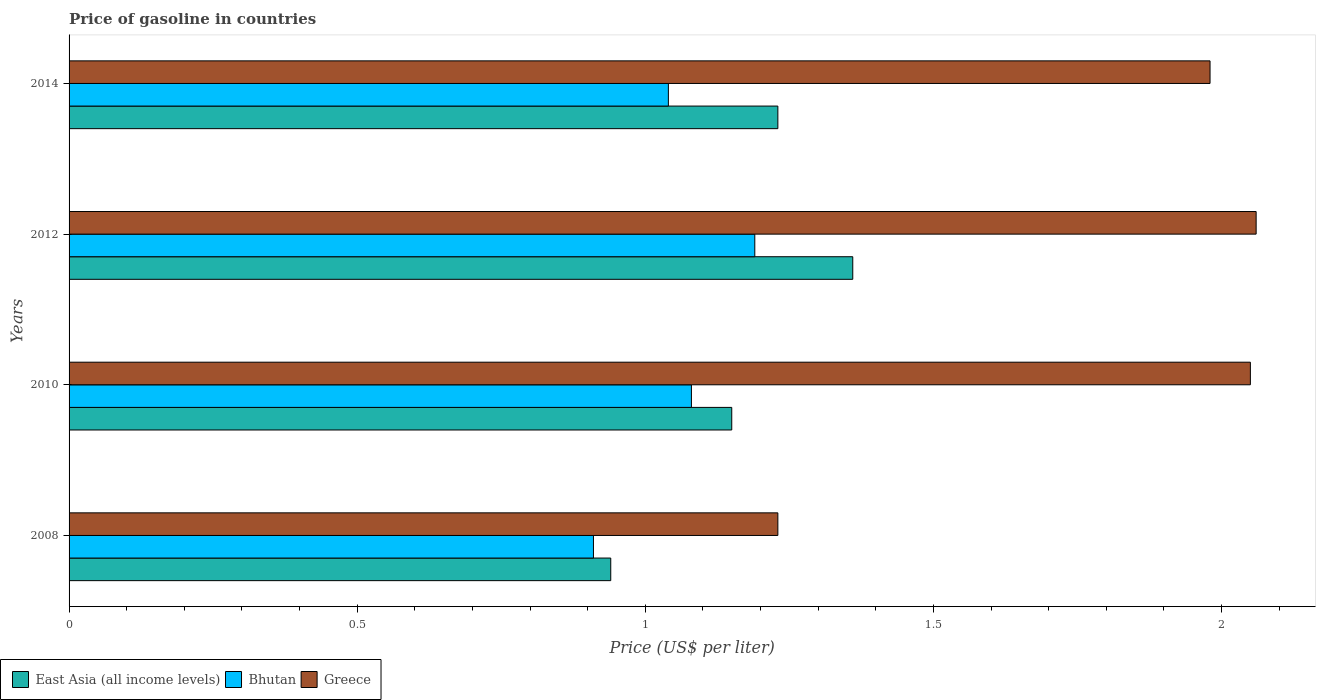How many different coloured bars are there?
Offer a terse response. 3. Are the number of bars on each tick of the Y-axis equal?
Your answer should be compact. Yes. How many bars are there on the 4th tick from the top?
Your answer should be compact. 3. What is the label of the 4th group of bars from the top?
Your response must be concise. 2008. In how many cases, is the number of bars for a given year not equal to the number of legend labels?
Provide a succinct answer. 0. What is the price of gasoline in Bhutan in 2008?
Your response must be concise. 0.91. Across all years, what is the maximum price of gasoline in Greece?
Ensure brevity in your answer.  2.06. Across all years, what is the minimum price of gasoline in Greece?
Provide a short and direct response. 1.23. What is the total price of gasoline in East Asia (all income levels) in the graph?
Offer a terse response. 4.68. What is the difference between the price of gasoline in East Asia (all income levels) in 2008 and that in 2014?
Provide a succinct answer. -0.29. What is the difference between the price of gasoline in East Asia (all income levels) in 2010 and the price of gasoline in Greece in 2014?
Keep it short and to the point. -0.83. What is the average price of gasoline in Bhutan per year?
Give a very brief answer. 1.06. In the year 2012, what is the difference between the price of gasoline in Greece and price of gasoline in Bhutan?
Your answer should be compact. 0.87. What is the ratio of the price of gasoline in Greece in 2010 to that in 2014?
Provide a succinct answer. 1.04. Is the price of gasoline in Greece in 2010 less than that in 2014?
Keep it short and to the point. No. What is the difference between the highest and the second highest price of gasoline in East Asia (all income levels)?
Offer a very short reply. 0.13. What is the difference between the highest and the lowest price of gasoline in Bhutan?
Keep it short and to the point. 0.28. Is the sum of the price of gasoline in East Asia (all income levels) in 2010 and 2014 greater than the maximum price of gasoline in Bhutan across all years?
Your answer should be very brief. Yes. What does the 3rd bar from the top in 2012 represents?
Your answer should be very brief. East Asia (all income levels). What does the 2nd bar from the bottom in 2008 represents?
Make the answer very short. Bhutan. How many bars are there?
Your response must be concise. 12. Are all the bars in the graph horizontal?
Your response must be concise. Yes. How many years are there in the graph?
Offer a very short reply. 4. Are the values on the major ticks of X-axis written in scientific E-notation?
Your answer should be very brief. No. Does the graph contain any zero values?
Give a very brief answer. No. Does the graph contain grids?
Your response must be concise. No. How many legend labels are there?
Make the answer very short. 3. How are the legend labels stacked?
Your answer should be very brief. Horizontal. What is the title of the graph?
Your response must be concise. Price of gasoline in countries. What is the label or title of the X-axis?
Your answer should be compact. Price (US$ per liter). What is the Price (US$ per liter) in Bhutan in 2008?
Provide a short and direct response. 0.91. What is the Price (US$ per liter) of Greece in 2008?
Provide a succinct answer. 1.23. What is the Price (US$ per liter) of East Asia (all income levels) in 2010?
Provide a short and direct response. 1.15. What is the Price (US$ per liter) in Bhutan in 2010?
Offer a very short reply. 1.08. What is the Price (US$ per liter) in Greece in 2010?
Offer a terse response. 2.05. What is the Price (US$ per liter) in East Asia (all income levels) in 2012?
Offer a terse response. 1.36. What is the Price (US$ per liter) of Bhutan in 2012?
Your response must be concise. 1.19. What is the Price (US$ per liter) in Greece in 2012?
Provide a succinct answer. 2.06. What is the Price (US$ per liter) in East Asia (all income levels) in 2014?
Keep it short and to the point. 1.23. What is the Price (US$ per liter) in Bhutan in 2014?
Provide a short and direct response. 1.04. What is the Price (US$ per liter) in Greece in 2014?
Offer a terse response. 1.98. Across all years, what is the maximum Price (US$ per liter) of East Asia (all income levels)?
Give a very brief answer. 1.36. Across all years, what is the maximum Price (US$ per liter) of Bhutan?
Provide a short and direct response. 1.19. Across all years, what is the maximum Price (US$ per liter) in Greece?
Ensure brevity in your answer.  2.06. Across all years, what is the minimum Price (US$ per liter) in East Asia (all income levels)?
Offer a very short reply. 0.94. Across all years, what is the minimum Price (US$ per liter) of Bhutan?
Give a very brief answer. 0.91. Across all years, what is the minimum Price (US$ per liter) in Greece?
Ensure brevity in your answer.  1.23. What is the total Price (US$ per liter) of East Asia (all income levels) in the graph?
Keep it short and to the point. 4.68. What is the total Price (US$ per liter) of Bhutan in the graph?
Provide a short and direct response. 4.22. What is the total Price (US$ per liter) in Greece in the graph?
Provide a succinct answer. 7.32. What is the difference between the Price (US$ per liter) in East Asia (all income levels) in 2008 and that in 2010?
Your response must be concise. -0.21. What is the difference between the Price (US$ per liter) of Bhutan in 2008 and that in 2010?
Make the answer very short. -0.17. What is the difference between the Price (US$ per liter) in Greece in 2008 and that in 2010?
Your answer should be compact. -0.82. What is the difference between the Price (US$ per liter) of East Asia (all income levels) in 2008 and that in 2012?
Offer a very short reply. -0.42. What is the difference between the Price (US$ per liter) of Bhutan in 2008 and that in 2012?
Make the answer very short. -0.28. What is the difference between the Price (US$ per liter) of Greece in 2008 and that in 2012?
Provide a succinct answer. -0.83. What is the difference between the Price (US$ per liter) in East Asia (all income levels) in 2008 and that in 2014?
Your answer should be very brief. -0.29. What is the difference between the Price (US$ per liter) of Bhutan in 2008 and that in 2014?
Make the answer very short. -0.13. What is the difference between the Price (US$ per liter) in Greece in 2008 and that in 2014?
Your answer should be compact. -0.75. What is the difference between the Price (US$ per liter) in East Asia (all income levels) in 2010 and that in 2012?
Your response must be concise. -0.21. What is the difference between the Price (US$ per liter) in Bhutan in 2010 and that in 2012?
Keep it short and to the point. -0.11. What is the difference between the Price (US$ per liter) in Greece in 2010 and that in 2012?
Make the answer very short. -0.01. What is the difference between the Price (US$ per liter) in East Asia (all income levels) in 2010 and that in 2014?
Your response must be concise. -0.08. What is the difference between the Price (US$ per liter) in Greece in 2010 and that in 2014?
Make the answer very short. 0.07. What is the difference between the Price (US$ per liter) in East Asia (all income levels) in 2012 and that in 2014?
Offer a very short reply. 0.13. What is the difference between the Price (US$ per liter) in East Asia (all income levels) in 2008 and the Price (US$ per liter) in Bhutan in 2010?
Offer a very short reply. -0.14. What is the difference between the Price (US$ per liter) in East Asia (all income levels) in 2008 and the Price (US$ per liter) in Greece in 2010?
Your answer should be compact. -1.11. What is the difference between the Price (US$ per liter) in Bhutan in 2008 and the Price (US$ per liter) in Greece in 2010?
Keep it short and to the point. -1.14. What is the difference between the Price (US$ per liter) of East Asia (all income levels) in 2008 and the Price (US$ per liter) of Bhutan in 2012?
Your answer should be very brief. -0.25. What is the difference between the Price (US$ per liter) in East Asia (all income levels) in 2008 and the Price (US$ per liter) in Greece in 2012?
Ensure brevity in your answer.  -1.12. What is the difference between the Price (US$ per liter) of Bhutan in 2008 and the Price (US$ per liter) of Greece in 2012?
Make the answer very short. -1.15. What is the difference between the Price (US$ per liter) of East Asia (all income levels) in 2008 and the Price (US$ per liter) of Bhutan in 2014?
Keep it short and to the point. -0.1. What is the difference between the Price (US$ per liter) of East Asia (all income levels) in 2008 and the Price (US$ per liter) of Greece in 2014?
Provide a short and direct response. -1.04. What is the difference between the Price (US$ per liter) of Bhutan in 2008 and the Price (US$ per liter) of Greece in 2014?
Give a very brief answer. -1.07. What is the difference between the Price (US$ per liter) of East Asia (all income levels) in 2010 and the Price (US$ per liter) of Bhutan in 2012?
Your response must be concise. -0.04. What is the difference between the Price (US$ per liter) in East Asia (all income levels) in 2010 and the Price (US$ per liter) in Greece in 2012?
Make the answer very short. -0.91. What is the difference between the Price (US$ per liter) in Bhutan in 2010 and the Price (US$ per liter) in Greece in 2012?
Offer a terse response. -0.98. What is the difference between the Price (US$ per liter) of East Asia (all income levels) in 2010 and the Price (US$ per liter) of Bhutan in 2014?
Your answer should be compact. 0.11. What is the difference between the Price (US$ per liter) of East Asia (all income levels) in 2010 and the Price (US$ per liter) of Greece in 2014?
Offer a terse response. -0.83. What is the difference between the Price (US$ per liter) of Bhutan in 2010 and the Price (US$ per liter) of Greece in 2014?
Give a very brief answer. -0.9. What is the difference between the Price (US$ per liter) in East Asia (all income levels) in 2012 and the Price (US$ per liter) in Bhutan in 2014?
Make the answer very short. 0.32. What is the difference between the Price (US$ per liter) in East Asia (all income levels) in 2012 and the Price (US$ per liter) in Greece in 2014?
Your answer should be compact. -0.62. What is the difference between the Price (US$ per liter) of Bhutan in 2012 and the Price (US$ per liter) of Greece in 2014?
Keep it short and to the point. -0.79. What is the average Price (US$ per liter) in East Asia (all income levels) per year?
Offer a terse response. 1.17. What is the average Price (US$ per liter) in Bhutan per year?
Your answer should be compact. 1.05. What is the average Price (US$ per liter) in Greece per year?
Give a very brief answer. 1.83. In the year 2008, what is the difference between the Price (US$ per liter) in East Asia (all income levels) and Price (US$ per liter) in Greece?
Your answer should be very brief. -0.29. In the year 2008, what is the difference between the Price (US$ per liter) of Bhutan and Price (US$ per liter) of Greece?
Keep it short and to the point. -0.32. In the year 2010, what is the difference between the Price (US$ per liter) of East Asia (all income levels) and Price (US$ per liter) of Bhutan?
Make the answer very short. 0.07. In the year 2010, what is the difference between the Price (US$ per liter) of East Asia (all income levels) and Price (US$ per liter) of Greece?
Ensure brevity in your answer.  -0.9. In the year 2010, what is the difference between the Price (US$ per liter) in Bhutan and Price (US$ per liter) in Greece?
Your answer should be compact. -0.97. In the year 2012, what is the difference between the Price (US$ per liter) of East Asia (all income levels) and Price (US$ per liter) of Bhutan?
Your answer should be very brief. 0.17. In the year 2012, what is the difference between the Price (US$ per liter) in East Asia (all income levels) and Price (US$ per liter) in Greece?
Give a very brief answer. -0.7. In the year 2012, what is the difference between the Price (US$ per liter) of Bhutan and Price (US$ per liter) of Greece?
Offer a very short reply. -0.87. In the year 2014, what is the difference between the Price (US$ per liter) in East Asia (all income levels) and Price (US$ per liter) in Bhutan?
Provide a short and direct response. 0.19. In the year 2014, what is the difference between the Price (US$ per liter) of East Asia (all income levels) and Price (US$ per liter) of Greece?
Your answer should be very brief. -0.75. In the year 2014, what is the difference between the Price (US$ per liter) in Bhutan and Price (US$ per liter) in Greece?
Your response must be concise. -0.94. What is the ratio of the Price (US$ per liter) of East Asia (all income levels) in 2008 to that in 2010?
Provide a succinct answer. 0.82. What is the ratio of the Price (US$ per liter) in Bhutan in 2008 to that in 2010?
Provide a short and direct response. 0.84. What is the ratio of the Price (US$ per liter) in East Asia (all income levels) in 2008 to that in 2012?
Give a very brief answer. 0.69. What is the ratio of the Price (US$ per liter) of Bhutan in 2008 to that in 2012?
Offer a terse response. 0.76. What is the ratio of the Price (US$ per liter) in Greece in 2008 to that in 2012?
Provide a short and direct response. 0.6. What is the ratio of the Price (US$ per liter) of East Asia (all income levels) in 2008 to that in 2014?
Offer a terse response. 0.76. What is the ratio of the Price (US$ per liter) of Greece in 2008 to that in 2014?
Make the answer very short. 0.62. What is the ratio of the Price (US$ per liter) of East Asia (all income levels) in 2010 to that in 2012?
Your response must be concise. 0.85. What is the ratio of the Price (US$ per liter) in Bhutan in 2010 to that in 2012?
Provide a short and direct response. 0.91. What is the ratio of the Price (US$ per liter) in East Asia (all income levels) in 2010 to that in 2014?
Offer a terse response. 0.94. What is the ratio of the Price (US$ per liter) of Bhutan in 2010 to that in 2014?
Ensure brevity in your answer.  1.04. What is the ratio of the Price (US$ per liter) of Greece in 2010 to that in 2014?
Provide a short and direct response. 1.04. What is the ratio of the Price (US$ per liter) of East Asia (all income levels) in 2012 to that in 2014?
Provide a short and direct response. 1.11. What is the ratio of the Price (US$ per liter) in Bhutan in 2012 to that in 2014?
Your response must be concise. 1.14. What is the ratio of the Price (US$ per liter) in Greece in 2012 to that in 2014?
Ensure brevity in your answer.  1.04. What is the difference between the highest and the second highest Price (US$ per liter) in East Asia (all income levels)?
Your answer should be compact. 0.13. What is the difference between the highest and the second highest Price (US$ per liter) in Bhutan?
Your answer should be compact. 0.11. What is the difference between the highest and the second highest Price (US$ per liter) in Greece?
Make the answer very short. 0.01. What is the difference between the highest and the lowest Price (US$ per liter) in East Asia (all income levels)?
Give a very brief answer. 0.42. What is the difference between the highest and the lowest Price (US$ per liter) of Bhutan?
Provide a succinct answer. 0.28. What is the difference between the highest and the lowest Price (US$ per liter) in Greece?
Offer a terse response. 0.83. 